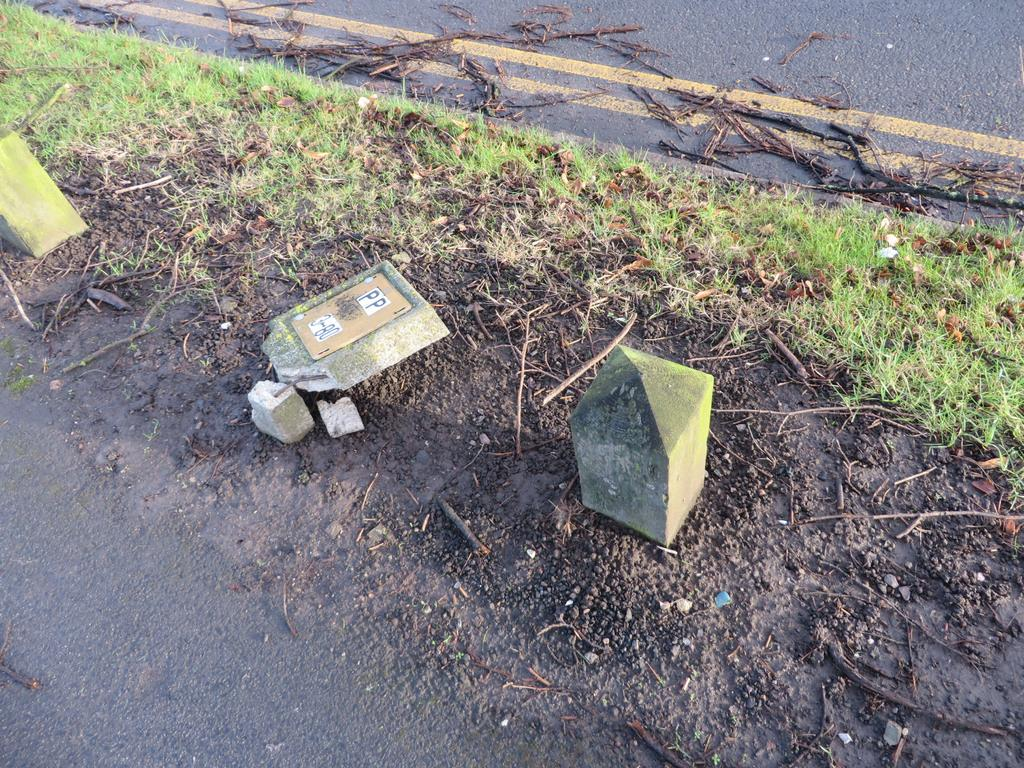What type of objects are on the ground in the image? There are barrier stones on the ground in the image. What else can be seen in the image besides the barrier stones? There are dried branches and grass visible in the image. Is there a designated route in the image? Yes, there is a pathway in the image. How many police officers are walking along the pathway in the image? There are no police officers or any indication of walking in the image. 